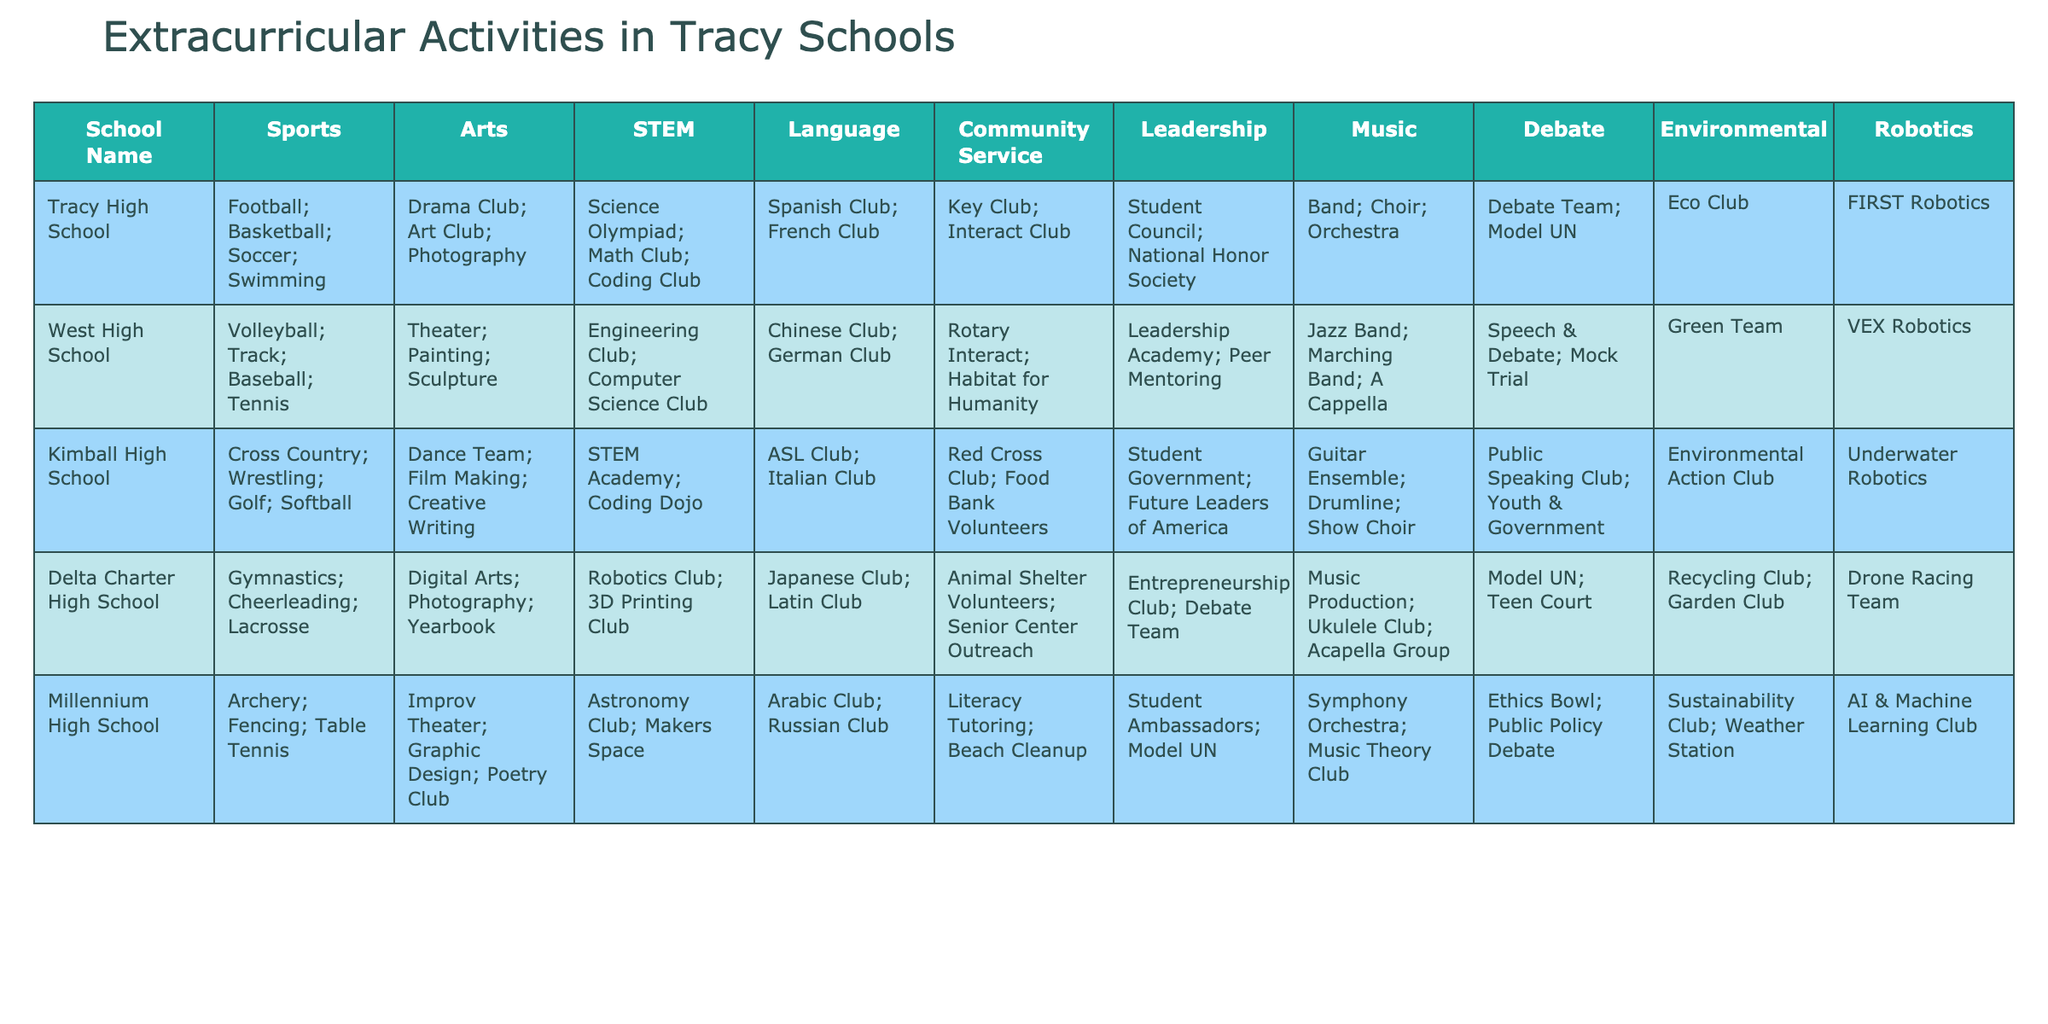What extracurricular activities does Tracy High School offer in the STEM category? By looking at the "STEM" column for Tracy High School, the activities listed are "Science Olympiad; Math Club; Coding Club."
Answer: Science Olympiad; Math Club; Coding Club Which school offers a Debate Team as an extracurricular activity? I can check the "Debate" column in the table and see that both Tracy High School and West High School offer a Debate Team.
Answer: Tracy High School, West High School How many sports activities does Kimball High School offer? In the "Sports" column for Kimball High School, the listed activities are "Cross Country; Wrestling; Golf; Softball," which total to four sports activities.
Answer: 4 Is there a school that offers Environmental activities, and if so, which one? I look at the "Environmental" column and see that all four schools (Tracy High School, West High School, Kimball High School, Delta Charter High School) have Environmental clubs or activities, while Millennium High School also offers a Sustainability Club.
Answer: Yes, all schools except Millennium High School Which school has the most different types of extracurricular activities listed? By reviewing the total number of activities listed per school across all categories, I find that Kimball High School has the highest count by offering a diverse range in sports, arts, STEM, language, community service, leadership, music, debate, environmental, and robotics activities.
Answer: Kimball High School How many clubs focus specifically on STEM in the Tracy area schools? By reviewing the "STEM" column for each school, I find that there are a total of five clubs listed across the schools: Science Olympiad, Math Club, Coding Club, Engineering Club, Computer Science Club, Robotics Club, and more, counting up to nine unique STEM-related clubs.
Answer: 9 Is there a school with both a Debate Team and a Robotics Club? Checking the different schools, I see that Kimball High School and Delta Charter High School offer both a Debate Club and a Robotics-related program.
Answer: Yes, Kimball High School, Delta Charter High School Which school has the most language clubs? By counting the distinct language clubs in each school's "Language" category, I find that Delta Charter High School offers 2 clubs (Japanese Club; Latin Club), while Tracy High School, West High School, and Kimball High School offer 2 clubs, making it a tie.
Answer: Tie: Delta Charter, Tracy, West, Kimball Are there any schools that offer Music activities? Looking at the "Music" column, I see that all five schools offer various Music activities.
Answer: Yes, all schools What is the total number of unique leadership programs across the schools? By reviewing each school's "Leadership" column, the unique programs yield Student Council, National Honor Society, Leadership Academy, Peer Mentoring, and more, totaling to eight distinct leadership initiatives offered across the schools.
Answer: 8 